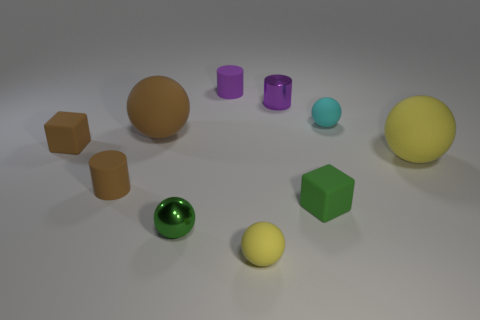Is the color of the tiny metallic ball the same as the shiny cylinder?
Make the answer very short. No. Are there any other things that are the same shape as the big yellow rubber object?
Keep it short and to the point. Yes. Is the number of small green blocks less than the number of matte cubes?
Offer a very short reply. Yes. The ball that is both behind the tiny brown cylinder and left of the cyan matte object is made of what material?
Provide a succinct answer. Rubber. Is there a tiny green block to the left of the small metal object that is behind the small green block?
Your answer should be very brief. No. How many objects are small matte balls or small brown cylinders?
Provide a short and direct response. 3. There is a tiny rubber thing that is both behind the brown rubber block and in front of the small purple rubber object; what shape is it?
Offer a very short reply. Sphere. Is the big sphere that is to the left of the small yellow sphere made of the same material as the green ball?
Offer a very short reply. No. How many objects are tiny rubber blocks or yellow matte balls behind the small green shiny sphere?
Ensure brevity in your answer.  3. There is another tiny block that is made of the same material as the brown block; what is its color?
Give a very brief answer. Green. 